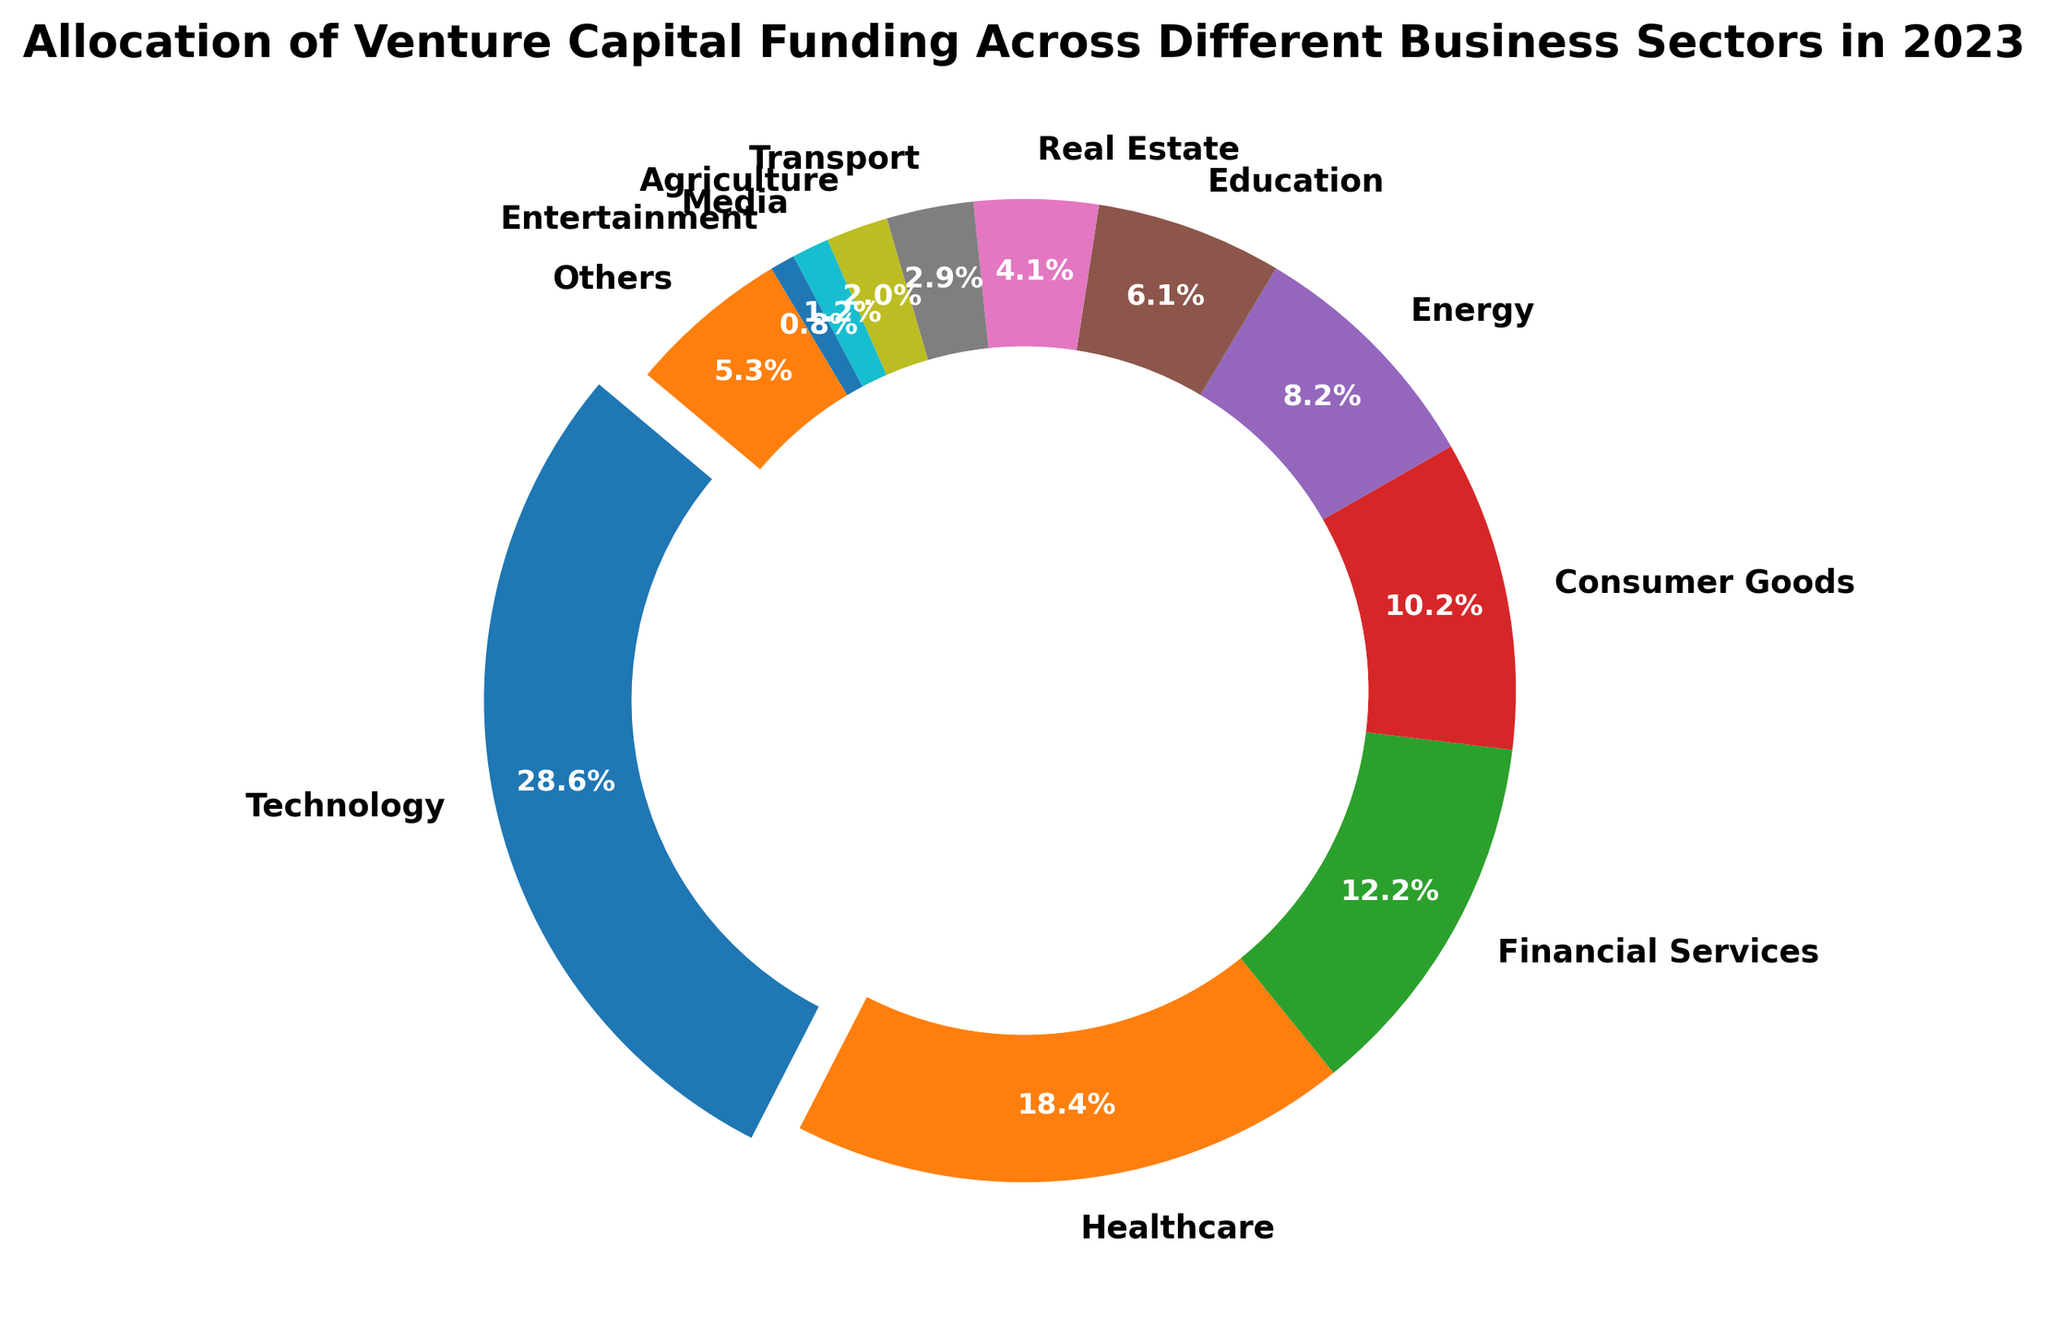What sector received the highest allocation of venture capital funding in 2023? The sector with the highest allocation is visually highlighted by being "exploded" outwards from the rest of the chart. This sector's label is also large and prominent.
Answer: Technology Which two sectors have the closest amounts of venture capital funding allocated to them? By visually comparing the sizes of the wedges, we notice that Financial Services and Consumer Goods have wedges of similar size. Their respective funding amounts also indicate closeness.
Answer: Financial Services and Consumer Goods Calculate the total funding allocated to the Technology, Healthcare, and Financial Services sectors combined. First, identify the funding amounts: Technology (70B), Healthcare (45B), and Financial Services (30B). Add these amounts together: 70 + 45 + 30 = 145 billion USD.
Answer: 145 billion USD How much more funding did the Technology sector receive compared to the Energy sector? From the chart, Technology received 70 billion USD, and Energy received 20 billion USD. Subtract the Energy funding from the Technology funding: 70 - 20 = 50 billion USD.
Answer: 50 billion USD What percentage of the total funding did the top three sectors combined (Technology, Healthcare, Financial Services) receive? Calculate the individual percentages of the top three sectors: Technology (29.4%), Healthcare (18.9%), and Financial Services (12.6%). Add these percentages together: 29.4 + 18.9 + 12.6 = 60.9%.
Answer: 60.9% Which sector received the least amount of venture capital funding? The smallest wedge on the chart corresponds to the Entertainment sector, which has the lowest funding amount listed (2 billion USD).
Answer: Entertainment How does the funding allocated to Education compare to that allocated to Real Estate? The pie chart indicates that Education has a larger wedge than Real Estate. Funding amounts are 15 billion for Education and 10 billion for Real Estate, meaning Education received 5 billion USD more.
Answer: Education received 5 billion USD more What is the combined percentage of funding received by the Transport and Media sectors? Identify the individual percentages for Transport (2.9%) and Media (1.3%) sectors from the pie chart. Add these percentages together: 2.9 + 1.3 = 4.2%.
Answer: 4.2% By how much does the funding for Agriculture exceed the combined funding for Media and Entertainment? Agriculture has 5 billion USD of funding. Media and Entertainment combined have 3 billion + 2 billion = 5 billion USD, which means Agriculture funding doesn't exceed the combined funding.
Answer: 0 billion USD What visual feature highlights the sector with the highest percentage of venture capital funding? The Technology sector wedge is visually separated from the rest to highlight its prominence, and it is the largest section in the ring chart.
Answer: Exploded wedge 